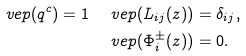<formula> <loc_0><loc_0><loc_500><loc_500>\ v e p ( q ^ { c } ) = 1 & \quad \ v e p ( L _ { i j } ( z ) ) = \delta _ { i j } , \\ & \quad \ v e p ( \Phi _ { i } ^ { \pm } ( z ) ) = 0 .</formula> 